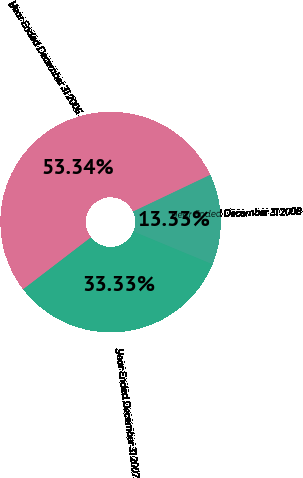Convert chart to OTSL. <chart><loc_0><loc_0><loc_500><loc_500><pie_chart><fcel>Year Ended December 31 2008<fcel>Year Ended December 31 2007<fcel>Year Ended December 31 2006<nl><fcel>13.33%<fcel>33.33%<fcel>53.33%<nl></chart> 